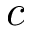<formula> <loc_0><loc_0><loc_500><loc_500>c</formula> 